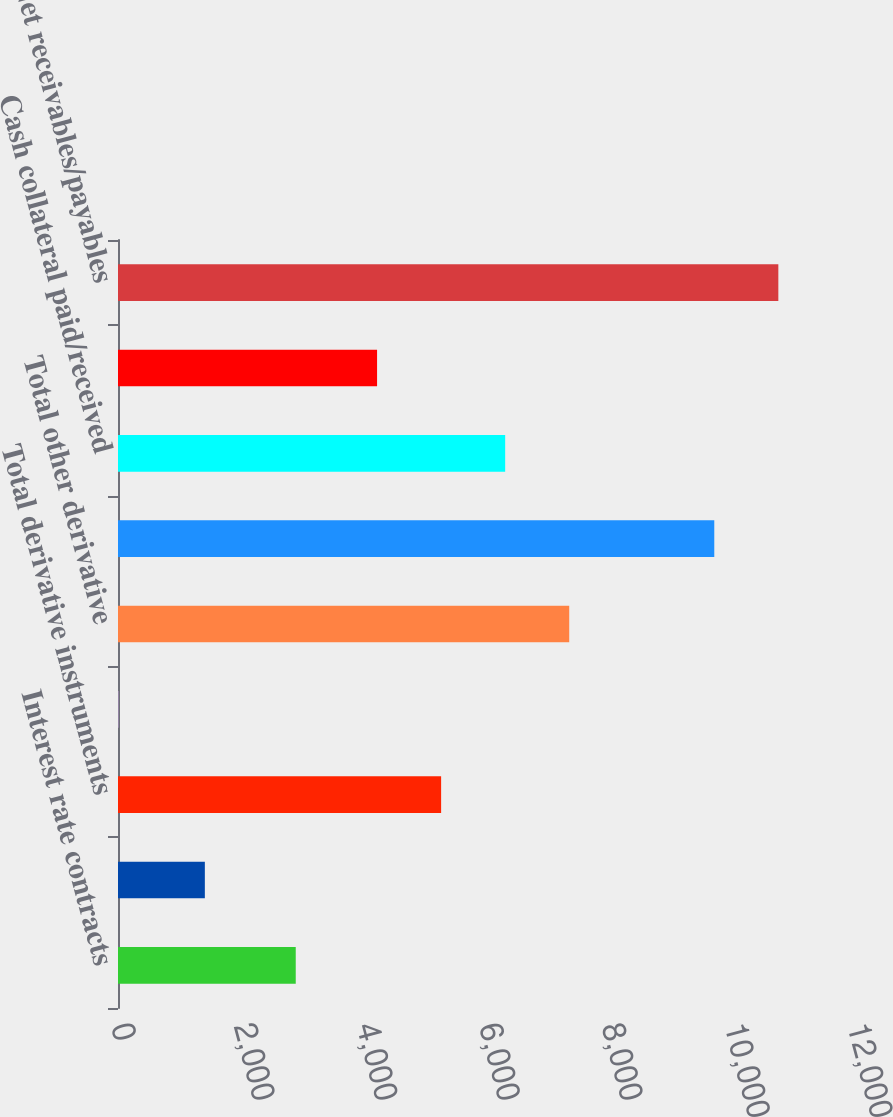<chart> <loc_0><loc_0><loc_500><loc_500><bar_chart><fcel>Interest rate contracts<fcel>Foreign exchange contracts<fcel>Total derivative instruments<fcel>Equity contracts<fcel>Total other derivative<fcel>Total derivatives<fcel>Cash collateral paid/received<fcel>Less Netting agreements and<fcel>Net receivables/payables<nl><fcel>2898<fcel>1416<fcel>5268.3<fcel>5<fcel>7356.9<fcel>9722<fcel>6312.6<fcel>4224<fcel>10766.3<nl></chart> 